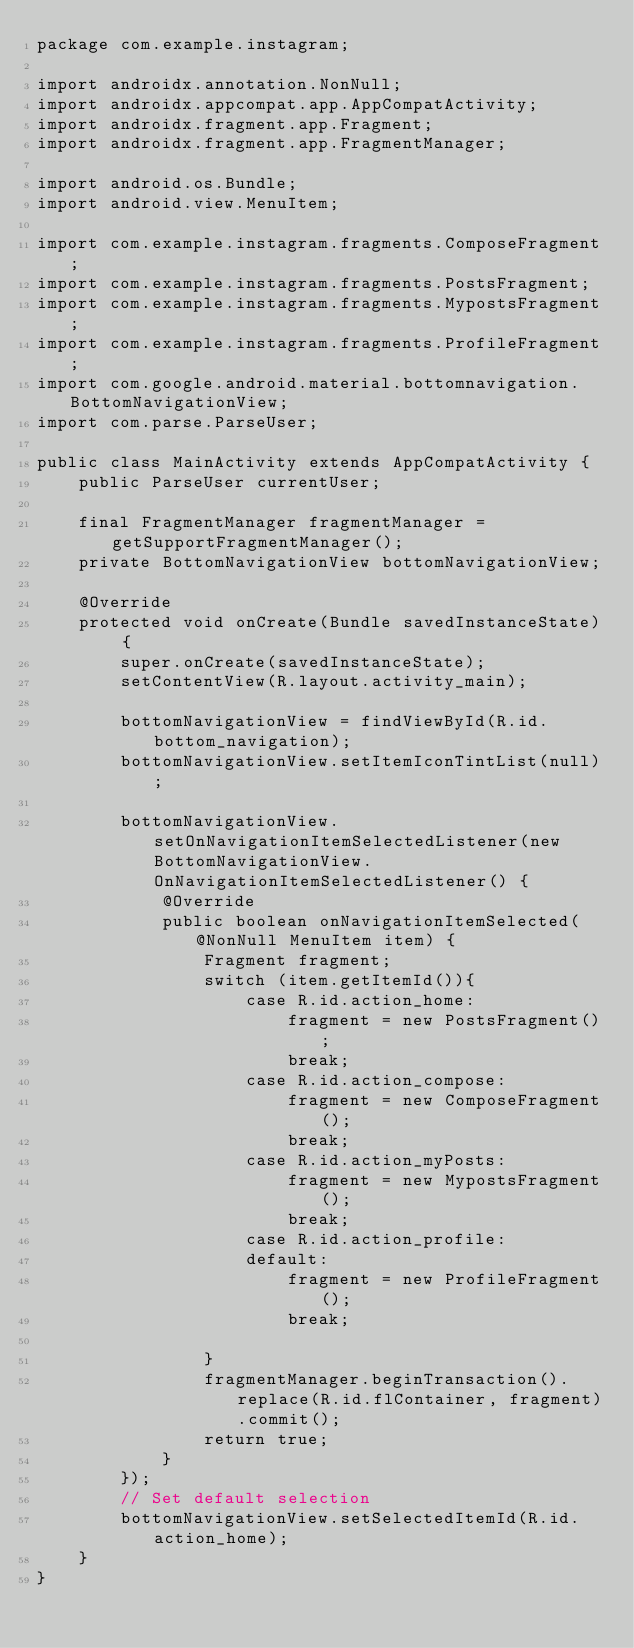Convert code to text. <code><loc_0><loc_0><loc_500><loc_500><_Java_>package com.example.instagram;

import androidx.annotation.NonNull;
import androidx.appcompat.app.AppCompatActivity;
import androidx.fragment.app.Fragment;
import androidx.fragment.app.FragmentManager;

import android.os.Bundle;
import android.view.MenuItem;

import com.example.instagram.fragments.ComposeFragment;
import com.example.instagram.fragments.PostsFragment;
import com.example.instagram.fragments.MypostsFragment;
import com.example.instagram.fragments.ProfileFragment;
import com.google.android.material.bottomnavigation.BottomNavigationView;
import com.parse.ParseUser;

public class MainActivity extends AppCompatActivity {
    public ParseUser currentUser;

    final FragmentManager fragmentManager = getSupportFragmentManager();
    private BottomNavigationView bottomNavigationView;

    @Override
    protected void onCreate(Bundle savedInstanceState) {
        super.onCreate(savedInstanceState);
        setContentView(R.layout.activity_main);

        bottomNavigationView = findViewById(R.id.bottom_navigation);
        bottomNavigationView.setItemIconTintList(null);

        bottomNavigationView.setOnNavigationItemSelectedListener(new BottomNavigationView.OnNavigationItemSelectedListener() {
            @Override
            public boolean onNavigationItemSelected(@NonNull MenuItem item) {
                Fragment fragment;
                switch (item.getItemId()){
                    case R.id.action_home:
                        fragment = new PostsFragment();
                        break;
                    case R.id.action_compose:
                        fragment = new ComposeFragment();
                        break;
                    case R.id.action_myPosts:
                        fragment = new MypostsFragment();
                        break;
                    case R.id.action_profile:
                    default:
                        fragment = new ProfileFragment();
                        break;

                }
                fragmentManager.beginTransaction().replace(R.id.flContainer, fragment).commit();
                return true;
            }
        });
        // Set default selection
        bottomNavigationView.setSelectedItemId(R.id.action_home);
    }
}</code> 